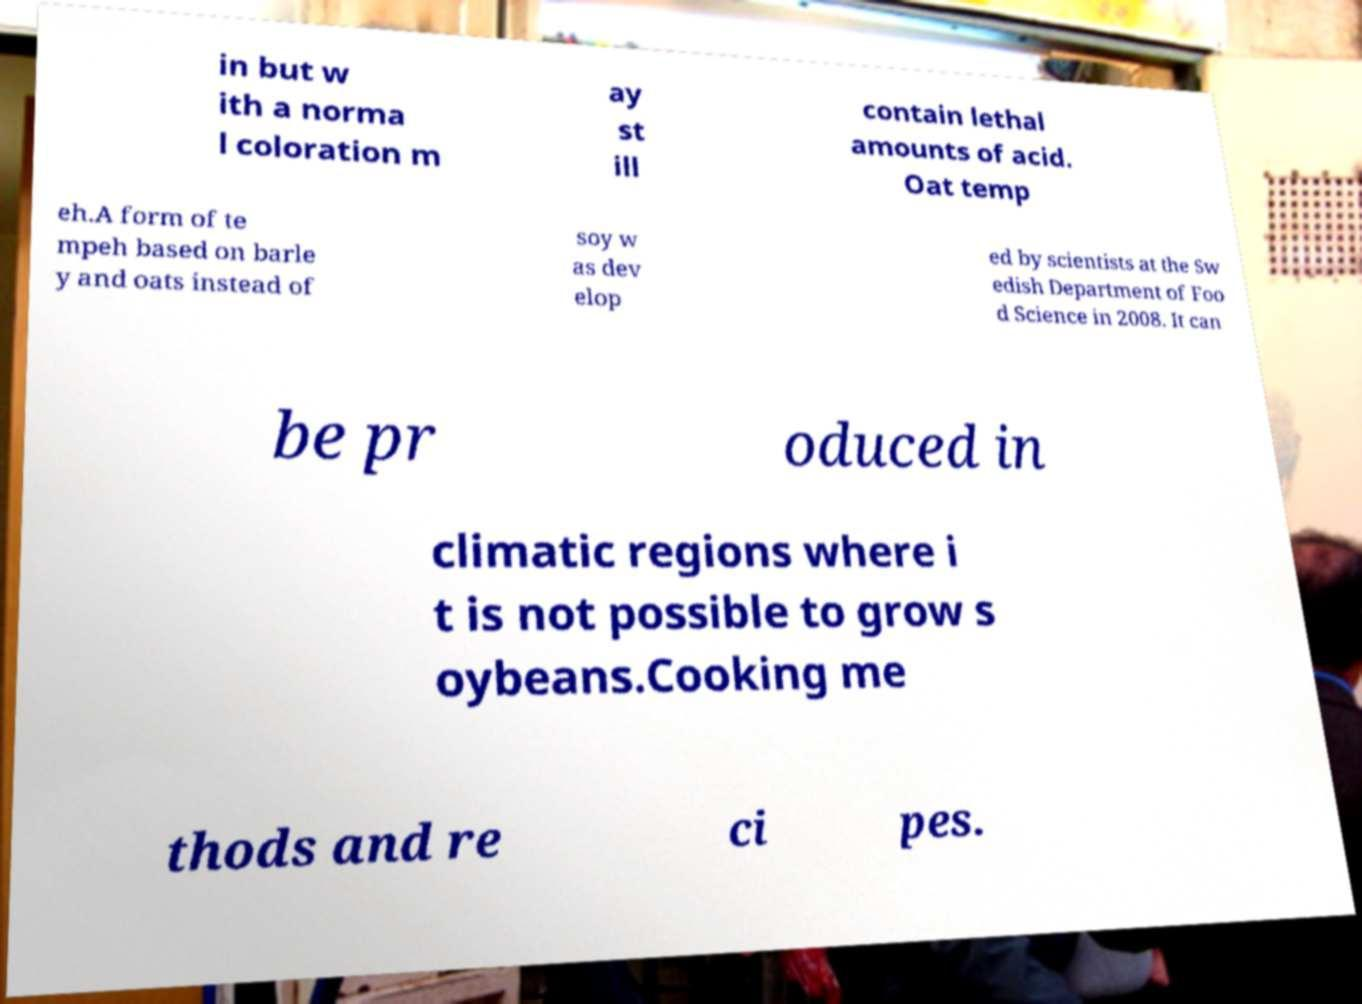Please read and relay the text visible in this image. What does it say? in but w ith a norma l coloration m ay st ill contain lethal amounts of acid. Oat temp eh.A form of te mpeh based on barle y and oats instead of soy w as dev elop ed by scientists at the Sw edish Department of Foo d Science in 2008. It can be pr oduced in climatic regions where i t is not possible to grow s oybeans.Cooking me thods and re ci pes. 